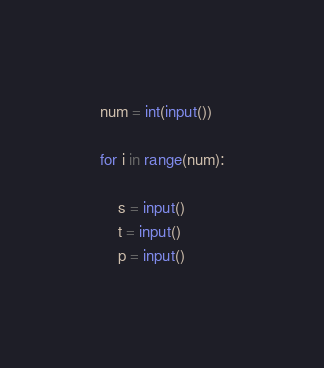Convert code to text. <code><loc_0><loc_0><loc_500><loc_500><_Python_>num = int(input())

for i in range(num):

    s = input()
    t = input()
    p = input()
</code> 